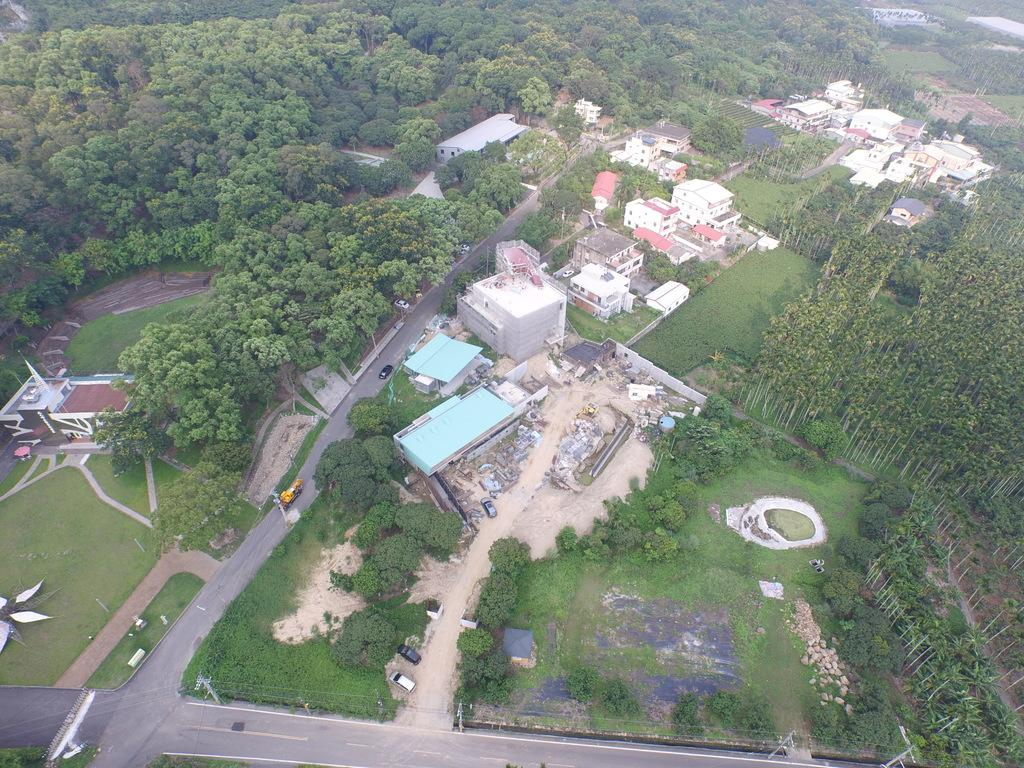What perspective is the image taken from? The image is taken from a top view. What type of structures can be seen in the image? There are many buildings in the image. What type of vehicles are present in the image? There are cars in the image. What type of pathways are visible in the image? There are roads in the image. What type of vegetation is present in the image? There are trees in the image. What type of ground cover is present at the bottom of the image? There is green grass on the ground at the bottom of the image. How many tails can be seen on the cars in the image? There are no tails visible on the cars in the image, as cars do not have tails. Where is the mailbox located in the image? There is no mailbox present in the image. 